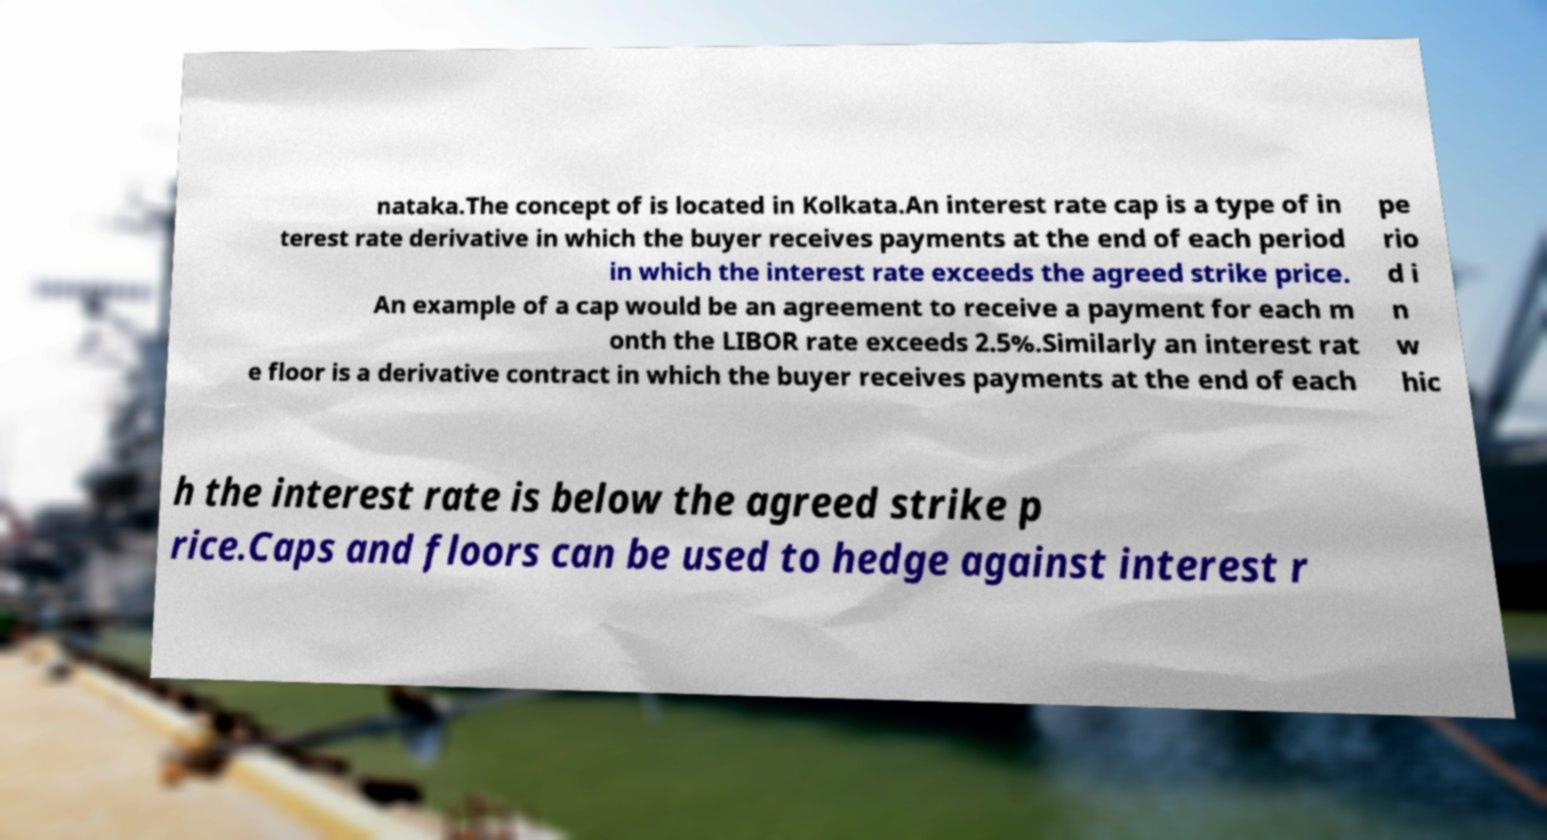Please read and relay the text visible in this image. What does it say? nataka.The concept of is located in Kolkata.An interest rate cap is a type of in terest rate derivative in which the buyer receives payments at the end of each period in which the interest rate exceeds the agreed strike price. An example of a cap would be an agreement to receive a payment for each m onth the LIBOR rate exceeds 2.5%.Similarly an interest rat e floor is a derivative contract in which the buyer receives payments at the end of each pe rio d i n w hic h the interest rate is below the agreed strike p rice.Caps and floors can be used to hedge against interest r 